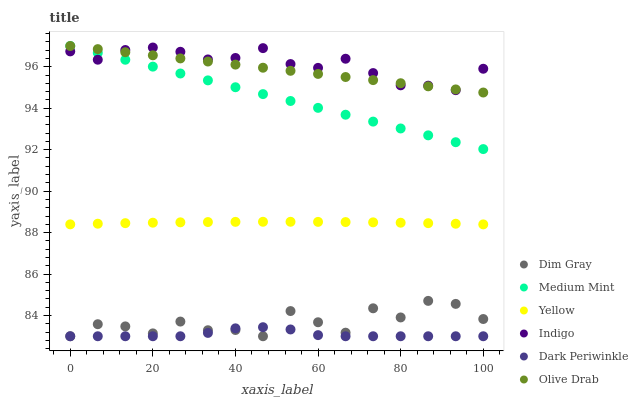Does Dark Periwinkle have the minimum area under the curve?
Answer yes or no. Yes. Does Indigo have the maximum area under the curve?
Answer yes or no. Yes. Does Dim Gray have the minimum area under the curve?
Answer yes or no. No. Does Dim Gray have the maximum area under the curve?
Answer yes or no. No. Is Olive Drab the smoothest?
Answer yes or no. Yes. Is Dim Gray the roughest?
Answer yes or no. Yes. Is Indigo the smoothest?
Answer yes or no. No. Is Indigo the roughest?
Answer yes or no. No. Does Dim Gray have the lowest value?
Answer yes or no. Yes. Does Indigo have the lowest value?
Answer yes or no. No. Does Olive Drab have the highest value?
Answer yes or no. Yes. Does Dim Gray have the highest value?
Answer yes or no. No. Is Dark Periwinkle less than Yellow?
Answer yes or no. Yes. Is Medium Mint greater than Dim Gray?
Answer yes or no. Yes. Does Dim Gray intersect Dark Periwinkle?
Answer yes or no. Yes. Is Dim Gray less than Dark Periwinkle?
Answer yes or no. No. Is Dim Gray greater than Dark Periwinkle?
Answer yes or no. No. Does Dark Periwinkle intersect Yellow?
Answer yes or no. No. 